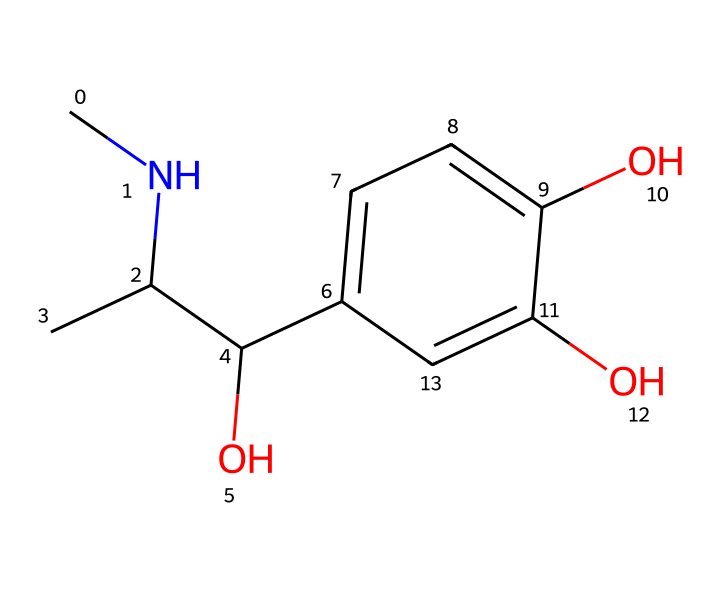What is the molecular formula of this chemical? To determine the molecular formula, count the atoms of each element in the given SMILES representation. The structure contains 12 carbon atoms, 17 hydrogen atoms, and 3 oxygen atoms, leading to the molecular formula C12H17O3.
Answer: C12H17O3 How many aromatic rings are present in this structure? The provided SMILES includes a benzene-like structure indicated by 'c' characters, which signifies aromatic carbon atoms. There is one aromatic ring in the chemical structure.
Answer: 1 What functional groups are present in this chemical? Analyzing the structure for specific functional groups reveals the presence of hydroxyl groups (-OH) attached to the aromatic ring and an alcohol group, indicating it has both phenolic and alcohol functional groups.
Answer: phenolic and alcohol Which element is represented by the letter 'N' in the structure, if present? There is a 'N' in the structure, indicating the presence of a nitrogen atom. In many hormones, nitrogen plays a critical role in binding and signaling. Since 'N' is present, it confirms nitrogen is a part of this chemical.
Answer: nitrogen Is this chemical a steroid or non-steroid hormone? This chemical does not have the characteristic steroid structure, which typically includes four fused rings; instead, it is more similar to a catecholamine, suggesting it is a non-steroid hormone.
Answer: non-steroid 